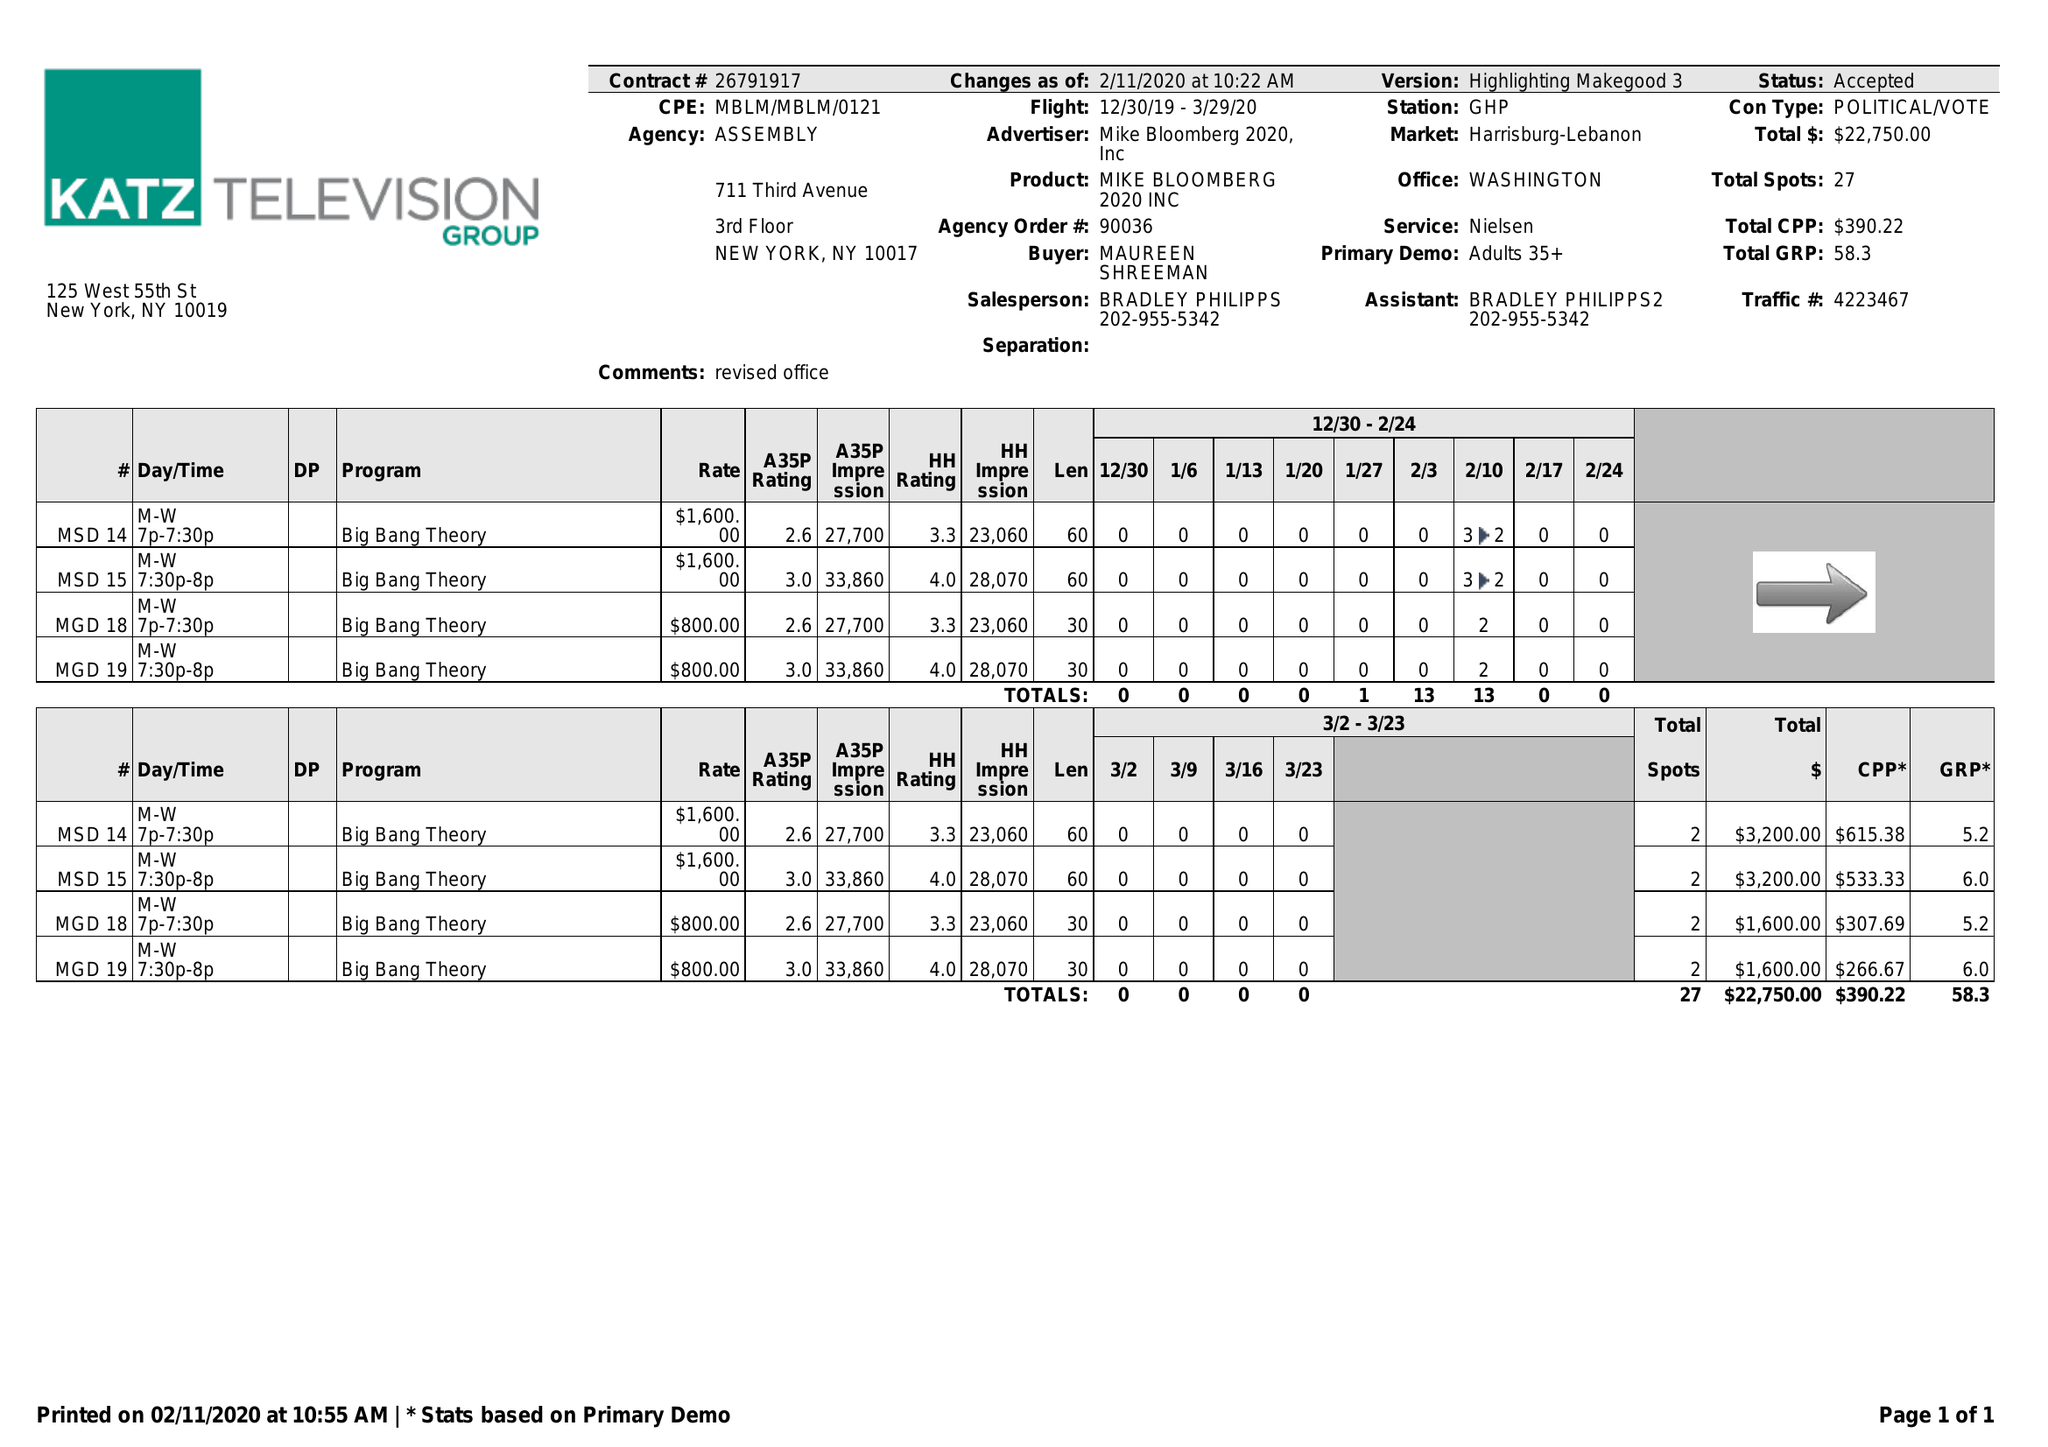What is the value for the gross_amount?
Answer the question using a single word or phrase. 22750.00 